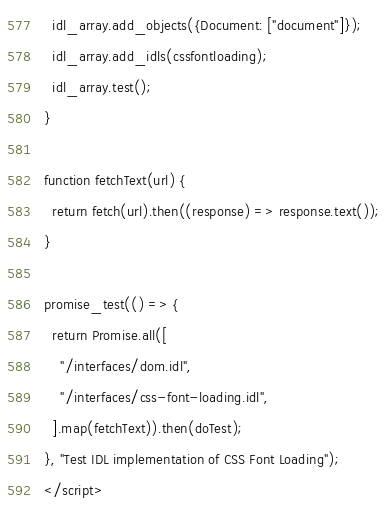Convert code to text. <code><loc_0><loc_0><loc_500><loc_500><_HTML_>  idl_array.add_objects({Document: ["document"]});
  idl_array.add_idls(cssfontloading);
  idl_array.test();
}

function fetchText(url) {
  return fetch(url).then((response) => response.text());
}

promise_test(() => {
  return Promise.all([
    "/interfaces/dom.idl",
    "/interfaces/css-font-loading.idl",
  ].map(fetchText)).then(doTest);
}, "Test IDL implementation of CSS Font Loading");
</script>
</code> 